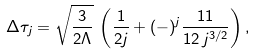<formula> <loc_0><loc_0><loc_500><loc_500>\Delta \tau _ { j } = \sqrt { \frac { 3 } { 2 \Lambda } } \, \left ( \frac { 1 } { 2 j } + ( - ) ^ { j } \frac { 1 1 } { 1 2 \, j ^ { 3 / 2 } } \right ) ,</formula> 